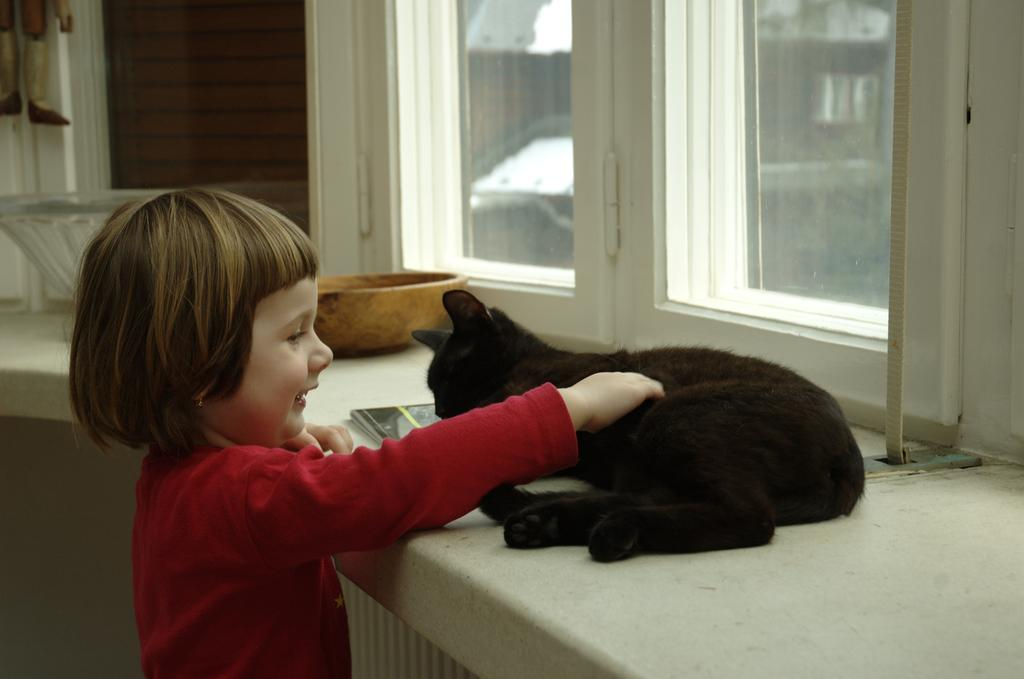Who is the main subject in the image? There is a girl in the image. What is the girl doing in the image? The girl is standing and smiling. What is the girl holding in the image? The girl is holding a cat with her hands. What other objects can be seen in the image? There are books and a bowl in the image. What is visible in the background of the image? There is a window in the image. What type of machine is being used to support the girl's education in the image? There is no machine present in the image, and the girl's education is not mentioned. 